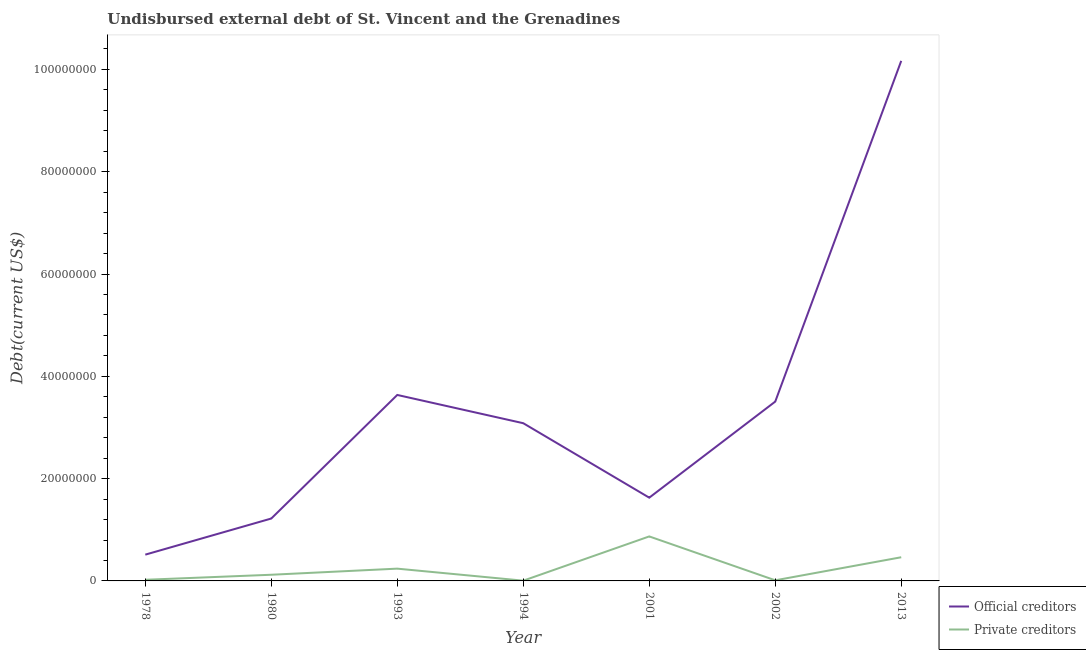Does the line corresponding to undisbursed external debt of private creditors intersect with the line corresponding to undisbursed external debt of official creditors?
Your answer should be compact. No. Is the number of lines equal to the number of legend labels?
Give a very brief answer. Yes. What is the undisbursed external debt of official creditors in 1978?
Your response must be concise. 5.14e+06. Across all years, what is the maximum undisbursed external debt of private creditors?
Your response must be concise. 8.70e+06. Across all years, what is the minimum undisbursed external debt of private creditors?
Your answer should be very brief. 5.10e+04. In which year was the undisbursed external debt of official creditors minimum?
Ensure brevity in your answer.  1978. What is the total undisbursed external debt of private creditors in the graph?
Offer a terse response. 1.73e+07. What is the difference between the undisbursed external debt of official creditors in 1993 and that in 2002?
Your answer should be very brief. 1.30e+06. What is the difference between the undisbursed external debt of private creditors in 1978 and the undisbursed external debt of official creditors in 2002?
Your answer should be very brief. -3.48e+07. What is the average undisbursed external debt of private creditors per year?
Your answer should be compact. 2.48e+06. In the year 2013, what is the difference between the undisbursed external debt of official creditors and undisbursed external debt of private creditors?
Offer a terse response. 9.70e+07. In how many years, is the undisbursed external debt of official creditors greater than 56000000 US$?
Offer a very short reply. 1. What is the ratio of the undisbursed external debt of official creditors in 1978 to that in 1993?
Provide a short and direct response. 0.14. What is the difference between the highest and the second highest undisbursed external debt of private creditors?
Give a very brief answer. 4.07e+06. What is the difference between the highest and the lowest undisbursed external debt of official creditors?
Keep it short and to the point. 9.65e+07. In how many years, is the undisbursed external debt of private creditors greater than the average undisbursed external debt of private creditors taken over all years?
Provide a short and direct response. 2. Is the sum of the undisbursed external debt of official creditors in 1993 and 2013 greater than the maximum undisbursed external debt of private creditors across all years?
Offer a terse response. Yes. Does the undisbursed external debt of private creditors monotonically increase over the years?
Ensure brevity in your answer.  No. Is the undisbursed external debt of official creditors strictly greater than the undisbursed external debt of private creditors over the years?
Provide a succinct answer. Yes. How many years are there in the graph?
Offer a terse response. 7. What is the difference between two consecutive major ticks on the Y-axis?
Give a very brief answer. 2.00e+07. Does the graph contain grids?
Give a very brief answer. No. Where does the legend appear in the graph?
Provide a succinct answer. Bottom right. How are the legend labels stacked?
Your response must be concise. Vertical. What is the title of the graph?
Keep it short and to the point. Undisbursed external debt of St. Vincent and the Grenadines. What is the label or title of the X-axis?
Your answer should be compact. Year. What is the label or title of the Y-axis?
Provide a short and direct response. Debt(current US$). What is the Debt(current US$) in Official creditors in 1978?
Provide a short and direct response. 5.14e+06. What is the Debt(current US$) in Private creditors in 1978?
Offer a terse response. 2.23e+05. What is the Debt(current US$) in Official creditors in 1980?
Offer a terse response. 1.22e+07. What is the Debt(current US$) of Private creditors in 1980?
Give a very brief answer. 1.21e+06. What is the Debt(current US$) of Official creditors in 1993?
Offer a terse response. 3.64e+07. What is the Debt(current US$) in Private creditors in 1993?
Provide a succinct answer. 2.40e+06. What is the Debt(current US$) of Official creditors in 1994?
Your response must be concise. 3.08e+07. What is the Debt(current US$) of Private creditors in 1994?
Your answer should be very brief. 5.10e+04. What is the Debt(current US$) of Official creditors in 2001?
Your answer should be very brief. 1.63e+07. What is the Debt(current US$) in Private creditors in 2001?
Keep it short and to the point. 8.70e+06. What is the Debt(current US$) of Official creditors in 2002?
Your answer should be very brief. 3.51e+07. What is the Debt(current US$) in Official creditors in 2013?
Provide a short and direct response. 1.02e+08. What is the Debt(current US$) in Private creditors in 2013?
Your answer should be compact. 4.63e+06. Across all years, what is the maximum Debt(current US$) in Official creditors?
Make the answer very short. 1.02e+08. Across all years, what is the maximum Debt(current US$) of Private creditors?
Give a very brief answer. 8.70e+06. Across all years, what is the minimum Debt(current US$) of Official creditors?
Provide a succinct answer. 5.14e+06. Across all years, what is the minimum Debt(current US$) in Private creditors?
Give a very brief answer. 5.10e+04. What is the total Debt(current US$) in Official creditors in the graph?
Provide a short and direct response. 2.38e+08. What is the total Debt(current US$) in Private creditors in the graph?
Keep it short and to the point. 1.73e+07. What is the difference between the Debt(current US$) of Official creditors in 1978 and that in 1980?
Provide a short and direct response. -7.06e+06. What is the difference between the Debt(current US$) of Private creditors in 1978 and that in 1980?
Your answer should be very brief. -9.84e+05. What is the difference between the Debt(current US$) of Official creditors in 1978 and that in 1993?
Make the answer very short. -3.12e+07. What is the difference between the Debt(current US$) in Private creditors in 1978 and that in 1993?
Provide a short and direct response. -2.18e+06. What is the difference between the Debt(current US$) of Official creditors in 1978 and that in 1994?
Your answer should be compact. -2.57e+07. What is the difference between the Debt(current US$) of Private creditors in 1978 and that in 1994?
Ensure brevity in your answer.  1.72e+05. What is the difference between the Debt(current US$) in Official creditors in 1978 and that in 2001?
Give a very brief answer. -1.11e+07. What is the difference between the Debt(current US$) in Private creditors in 1978 and that in 2001?
Provide a short and direct response. -8.48e+06. What is the difference between the Debt(current US$) of Official creditors in 1978 and that in 2002?
Your response must be concise. -2.99e+07. What is the difference between the Debt(current US$) of Private creditors in 1978 and that in 2002?
Keep it short and to the point. 1.03e+05. What is the difference between the Debt(current US$) of Official creditors in 1978 and that in 2013?
Ensure brevity in your answer.  -9.65e+07. What is the difference between the Debt(current US$) of Private creditors in 1978 and that in 2013?
Your answer should be compact. -4.40e+06. What is the difference between the Debt(current US$) of Official creditors in 1980 and that in 1993?
Provide a succinct answer. -2.42e+07. What is the difference between the Debt(current US$) of Private creditors in 1980 and that in 1993?
Provide a short and direct response. -1.19e+06. What is the difference between the Debt(current US$) in Official creditors in 1980 and that in 1994?
Provide a succinct answer. -1.86e+07. What is the difference between the Debt(current US$) in Private creditors in 1980 and that in 1994?
Offer a terse response. 1.16e+06. What is the difference between the Debt(current US$) of Official creditors in 1980 and that in 2001?
Ensure brevity in your answer.  -4.08e+06. What is the difference between the Debt(current US$) in Private creditors in 1980 and that in 2001?
Provide a succinct answer. -7.49e+06. What is the difference between the Debt(current US$) in Official creditors in 1980 and that in 2002?
Provide a short and direct response. -2.29e+07. What is the difference between the Debt(current US$) of Private creditors in 1980 and that in 2002?
Keep it short and to the point. 1.09e+06. What is the difference between the Debt(current US$) of Official creditors in 1980 and that in 2013?
Your answer should be compact. -8.95e+07. What is the difference between the Debt(current US$) in Private creditors in 1980 and that in 2013?
Keep it short and to the point. -3.42e+06. What is the difference between the Debt(current US$) in Official creditors in 1993 and that in 1994?
Your response must be concise. 5.52e+06. What is the difference between the Debt(current US$) in Private creditors in 1993 and that in 1994?
Ensure brevity in your answer.  2.35e+06. What is the difference between the Debt(current US$) of Official creditors in 1993 and that in 2001?
Your answer should be compact. 2.01e+07. What is the difference between the Debt(current US$) of Private creditors in 1993 and that in 2001?
Your answer should be very brief. -6.30e+06. What is the difference between the Debt(current US$) of Official creditors in 1993 and that in 2002?
Give a very brief answer. 1.30e+06. What is the difference between the Debt(current US$) in Private creditors in 1993 and that in 2002?
Provide a short and direct response. 2.28e+06. What is the difference between the Debt(current US$) of Official creditors in 1993 and that in 2013?
Make the answer very short. -6.53e+07. What is the difference between the Debt(current US$) in Private creditors in 1993 and that in 2013?
Offer a terse response. -2.23e+06. What is the difference between the Debt(current US$) in Official creditors in 1994 and that in 2001?
Keep it short and to the point. 1.46e+07. What is the difference between the Debt(current US$) of Private creditors in 1994 and that in 2001?
Provide a succinct answer. -8.65e+06. What is the difference between the Debt(current US$) in Official creditors in 1994 and that in 2002?
Keep it short and to the point. -4.23e+06. What is the difference between the Debt(current US$) in Private creditors in 1994 and that in 2002?
Your answer should be compact. -6.90e+04. What is the difference between the Debt(current US$) in Official creditors in 1994 and that in 2013?
Provide a short and direct response. -7.08e+07. What is the difference between the Debt(current US$) of Private creditors in 1994 and that in 2013?
Your response must be concise. -4.58e+06. What is the difference between the Debt(current US$) of Official creditors in 2001 and that in 2002?
Your answer should be compact. -1.88e+07. What is the difference between the Debt(current US$) of Private creditors in 2001 and that in 2002?
Make the answer very short. 8.58e+06. What is the difference between the Debt(current US$) of Official creditors in 2001 and that in 2013?
Provide a short and direct response. -8.54e+07. What is the difference between the Debt(current US$) in Private creditors in 2001 and that in 2013?
Provide a succinct answer. 4.07e+06. What is the difference between the Debt(current US$) of Official creditors in 2002 and that in 2013?
Give a very brief answer. -6.66e+07. What is the difference between the Debt(current US$) in Private creditors in 2002 and that in 2013?
Offer a terse response. -4.51e+06. What is the difference between the Debt(current US$) in Official creditors in 1978 and the Debt(current US$) in Private creditors in 1980?
Make the answer very short. 3.93e+06. What is the difference between the Debt(current US$) of Official creditors in 1978 and the Debt(current US$) of Private creditors in 1993?
Your answer should be very brief. 2.74e+06. What is the difference between the Debt(current US$) in Official creditors in 1978 and the Debt(current US$) in Private creditors in 1994?
Make the answer very short. 5.09e+06. What is the difference between the Debt(current US$) in Official creditors in 1978 and the Debt(current US$) in Private creditors in 2001?
Make the answer very short. -3.56e+06. What is the difference between the Debt(current US$) of Official creditors in 1978 and the Debt(current US$) of Private creditors in 2002?
Keep it short and to the point. 5.02e+06. What is the difference between the Debt(current US$) of Official creditors in 1978 and the Debt(current US$) of Private creditors in 2013?
Give a very brief answer. 5.10e+05. What is the difference between the Debt(current US$) of Official creditors in 1980 and the Debt(current US$) of Private creditors in 1993?
Offer a very short reply. 9.80e+06. What is the difference between the Debt(current US$) in Official creditors in 1980 and the Debt(current US$) in Private creditors in 1994?
Provide a short and direct response. 1.21e+07. What is the difference between the Debt(current US$) of Official creditors in 1980 and the Debt(current US$) of Private creditors in 2001?
Your response must be concise. 3.50e+06. What is the difference between the Debt(current US$) of Official creditors in 1980 and the Debt(current US$) of Private creditors in 2002?
Ensure brevity in your answer.  1.21e+07. What is the difference between the Debt(current US$) of Official creditors in 1980 and the Debt(current US$) of Private creditors in 2013?
Your answer should be very brief. 7.57e+06. What is the difference between the Debt(current US$) of Official creditors in 1993 and the Debt(current US$) of Private creditors in 1994?
Provide a succinct answer. 3.63e+07. What is the difference between the Debt(current US$) in Official creditors in 1993 and the Debt(current US$) in Private creditors in 2001?
Provide a short and direct response. 2.77e+07. What is the difference between the Debt(current US$) of Official creditors in 1993 and the Debt(current US$) of Private creditors in 2002?
Provide a succinct answer. 3.62e+07. What is the difference between the Debt(current US$) of Official creditors in 1993 and the Debt(current US$) of Private creditors in 2013?
Your answer should be compact. 3.17e+07. What is the difference between the Debt(current US$) of Official creditors in 1994 and the Debt(current US$) of Private creditors in 2001?
Offer a terse response. 2.21e+07. What is the difference between the Debt(current US$) in Official creditors in 1994 and the Debt(current US$) in Private creditors in 2002?
Keep it short and to the point. 3.07e+07. What is the difference between the Debt(current US$) in Official creditors in 1994 and the Debt(current US$) in Private creditors in 2013?
Ensure brevity in your answer.  2.62e+07. What is the difference between the Debt(current US$) of Official creditors in 2001 and the Debt(current US$) of Private creditors in 2002?
Provide a short and direct response. 1.62e+07. What is the difference between the Debt(current US$) in Official creditors in 2001 and the Debt(current US$) in Private creditors in 2013?
Your answer should be compact. 1.16e+07. What is the difference between the Debt(current US$) in Official creditors in 2002 and the Debt(current US$) in Private creditors in 2013?
Keep it short and to the point. 3.04e+07. What is the average Debt(current US$) in Official creditors per year?
Give a very brief answer. 3.39e+07. What is the average Debt(current US$) in Private creditors per year?
Your answer should be compact. 2.48e+06. In the year 1978, what is the difference between the Debt(current US$) in Official creditors and Debt(current US$) in Private creditors?
Your answer should be compact. 4.92e+06. In the year 1980, what is the difference between the Debt(current US$) of Official creditors and Debt(current US$) of Private creditors?
Provide a short and direct response. 1.10e+07. In the year 1993, what is the difference between the Debt(current US$) in Official creditors and Debt(current US$) in Private creditors?
Your answer should be compact. 3.40e+07. In the year 1994, what is the difference between the Debt(current US$) of Official creditors and Debt(current US$) of Private creditors?
Make the answer very short. 3.08e+07. In the year 2001, what is the difference between the Debt(current US$) of Official creditors and Debt(current US$) of Private creditors?
Keep it short and to the point. 7.58e+06. In the year 2002, what is the difference between the Debt(current US$) in Official creditors and Debt(current US$) in Private creditors?
Your answer should be very brief. 3.49e+07. In the year 2013, what is the difference between the Debt(current US$) in Official creditors and Debt(current US$) in Private creditors?
Your answer should be very brief. 9.70e+07. What is the ratio of the Debt(current US$) in Official creditors in 1978 to that in 1980?
Provide a succinct answer. 0.42. What is the ratio of the Debt(current US$) in Private creditors in 1978 to that in 1980?
Keep it short and to the point. 0.18. What is the ratio of the Debt(current US$) in Official creditors in 1978 to that in 1993?
Offer a very short reply. 0.14. What is the ratio of the Debt(current US$) in Private creditors in 1978 to that in 1993?
Ensure brevity in your answer.  0.09. What is the ratio of the Debt(current US$) in Official creditors in 1978 to that in 1994?
Provide a succinct answer. 0.17. What is the ratio of the Debt(current US$) of Private creditors in 1978 to that in 1994?
Your response must be concise. 4.37. What is the ratio of the Debt(current US$) of Official creditors in 1978 to that in 2001?
Provide a short and direct response. 0.32. What is the ratio of the Debt(current US$) of Private creditors in 1978 to that in 2001?
Your answer should be compact. 0.03. What is the ratio of the Debt(current US$) of Official creditors in 1978 to that in 2002?
Offer a terse response. 0.15. What is the ratio of the Debt(current US$) of Private creditors in 1978 to that in 2002?
Provide a short and direct response. 1.86. What is the ratio of the Debt(current US$) in Official creditors in 1978 to that in 2013?
Keep it short and to the point. 0.05. What is the ratio of the Debt(current US$) of Private creditors in 1978 to that in 2013?
Offer a terse response. 0.05. What is the ratio of the Debt(current US$) of Official creditors in 1980 to that in 1993?
Give a very brief answer. 0.34. What is the ratio of the Debt(current US$) of Private creditors in 1980 to that in 1993?
Give a very brief answer. 0.5. What is the ratio of the Debt(current US$) in Official creditors in 1980 to that in 1994?
Provide a short and direct response. 0.4. What is the ratio of the Debt(current US$) of Private creditors in 1980 to that in 1994?
Provide a short and direct response. 23.67. What is the ratio of the Debt(current US$) in Official creditors in 1980 to that in 2001?
Offer a terse response. 0.75. What is the ratio of the Debt(current US$) in Private creditors in 1980 to that in 2001?
Ensure brevity in your answer.  0.14. What is the ratio of the Debt(current US$) of Official creditors in 1980 to that in 2002?
Ensure brevity in your answer.  0.35. What is the ratio of the Debt(current US$) in Private creditors in 1980 to that in 2002?
Your response must be concise. 10.06. What is the ratio of the Debt(current US$) of Official creditors in 1980 to that in 2013?
Provide a short and direct response. 0.12. What is the ratio of the Debt(current US$) in Private creditors in 1980 to that in 2013?
Give a very brief answer. 0.26. What is the ratio of the Debt(current US$) of Official creditors in 1993 to that in 1994?
Keep it short and to the point. 1.18. What is the ratio of the Debt(current US$) in Private creditors in 1993 to that in 1994?
Give a very brief answer. 47.06. What is the ratio of the Debt(current US$) of Official creditors in 1993 to that in 2001?
Your answer should be compact. 2.23. What is the ratio of the Debt(current US$) of Private creditors in 1993 to that in 2001?
Ensure brevity in your answer.  0.28. What is the ratio of the Debt(current US$) in Official creditors in 1993 to that in 2002?
Provide a short and direct response. 1.04. What is the ratio of the Debt(current US$) of Private creditors in 1993 to that in 2002?
Your answer should be very brief. 20. What is the ratio of the Debt(current US$) in Official creditors in 1993 to that in 2013?
Give a very brief answer. 0.36. What is the ratio of the Debt(current US$) in Private creditors in 1993 to that in 2013?
Your answer should be compact. 0.52. What is the ratio of the Debt(current US$) of Official creditors in 1994 to that in 2001?
Provide a short and direct response. 1.89. What is the ratio of the Debt(current US$) in Private creditors in 1994 to that in 2001?
Ensure brevity in your answer.  0.01. What is the ratio of the Debt(current US$) in Official creditors in 1994 to that in 2002?
Give a very brief answer. 0.88. What is the ratio of the Debt(current US$) of Private creditors in 1994 to that in 2002?
Your response must be concise. 0.42. What is the ratio of the Debt(current US$) of Official creditors in 1994 to that in 2013?
Your answer should be compact. 0.3. What is the ratio of the Debt(current US$) in Private creditors in 1994 to that in 2013?
Ensure brevity in your answer.  0.01. What is the ratio of the Debt(current US$) of Official creditors in 2001 to that in 2002?
Offer a very short reply. 0.46. What is the ratio of the Debt(current US$) of Private creditors in 2001 to that in 2002?
Provide a short and direct response. 72.5. What is the ratio of the Debt(current US$) in Official creditors in 2001 to that in 2013?
Your response must be concise. 0.16. What is the ratio of the Debt(current US$) of Private creditors in 2001 to that in 2013?
Offer a terse response. 1.88. What is the ratio of the Debt(current US$) in Official creditors in 2002 to that in 2013?
Ensure brevity in your answer.  0.34. What is the ratio of the Debt(current US$) in Private creditors in 2002 to that in 2013?
Your response must be concise. 0.03. What is the difference between the highest and the second highest Debt(current US$) in Official creditors?
Make the answer very short. 6.53e+07. What is the difference between the highest and the second highest Debt(current US$) in Private creditors?
Your response must be concise. 4.07e+06. What is the difference between the highest and the lowest Debt(current US$) in Official creditors?
Keep it short and to the point. 9.65e+07. What is the difference between the highest and the lowest Debt(current US$) in Private creditors?
Offer a terse response. 8.65e+06. 